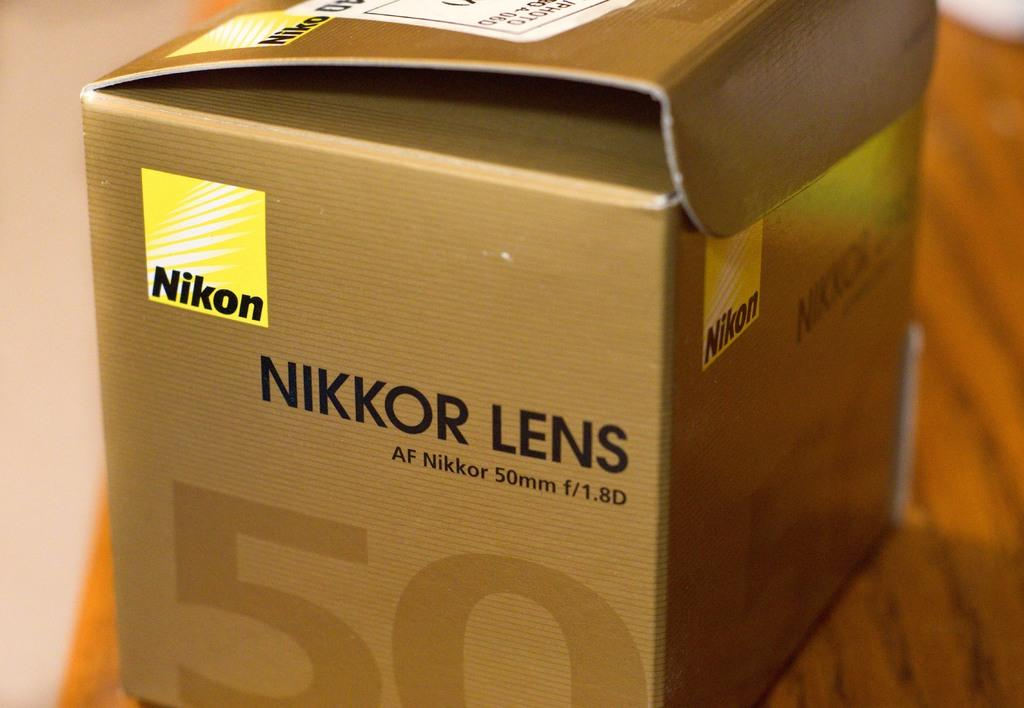Provide a one-sentence caption for the provided image. A Nikon Nikkor lens af nikkor 50 mm f/1.8 d box. 